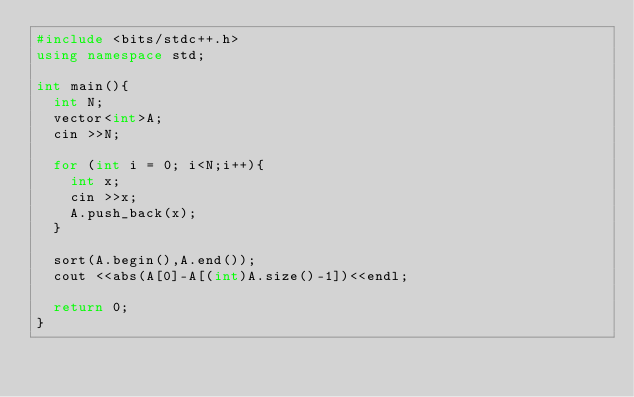Convert code to text. <code><loc_0><loc_0><loc_500><loc_500><_C++_>#include <bits/stdc++.h>
using namespace std;

int main(){
  int N;
  vector<int>A;
  cin >>N;

  for (int i = 0; i<N;i++){
    int x;
    cin >>x;
    A.push_back(x);
  }

  sort(A.begin(),A.end());
  cout <<abs(A[0]-A[(int)A.size()-1])<<endl;

  return 0;
}
</code> 